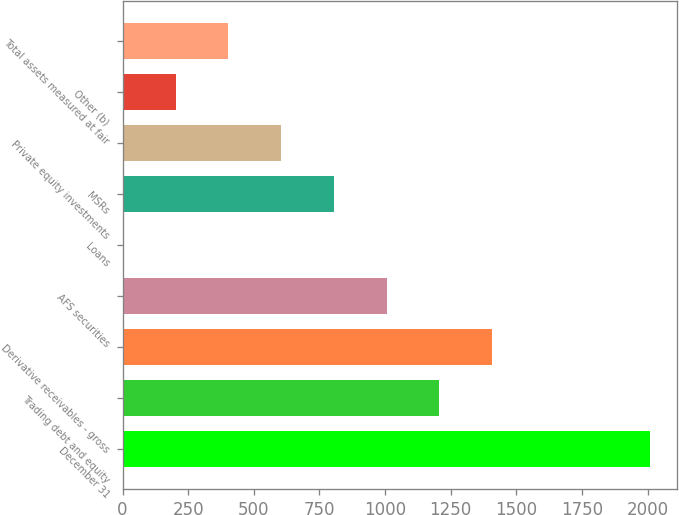<chart> <loc_0><loc_0><loc_500><loc_500><bar_chart><fcel>December 31<fcel>Trading debt and equity<fcel>Derivative receivables - gross<fcel>AFS securities<fcel>Loans<fcel>MSRs<fcel>Private equity investments<fcel>Other (b)<fcel>Total assets measured at fair<nl><fcel>2010<fcel>1206.6<fcel>1407.45<fcel>1005.75<fcel>1.5<fcel>804.9<fcel>604.05<fcel>202.35<fcel>403.2<nl></chart> 